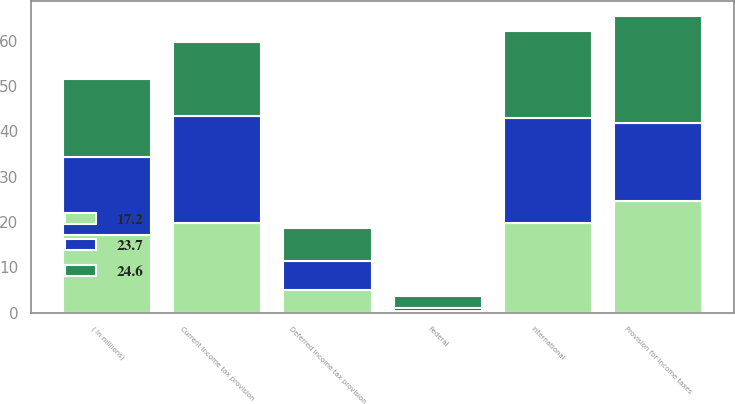Convert chart to OTSL. <chart><loc_0><loc_0><loc_500><loc_500><stacked_bar_chart><ecel><fcel>( in millions)<fcel>Federal<fcel>International<fcel>Current income tax provision<fcel>Deferred income tax provision<fcel>Provision for income taxes<nl><fcel>24.6<fcel>17.2<fcel>2.8<fcel>19.2<fcel>16.4<fcel>7.3<fcel>23.7<nl><fcel>23.7<fcel>17.2<fcel>0.5<fcel>23.1<fcel>23.6<fcel>6.4<fcel>17.2<nl><fcel>17.2<fcel>17.2<fcel>0.4<fcel>19.8<fcel>19.7<fcel>4.9<fcel>24.6<nl></chart> 